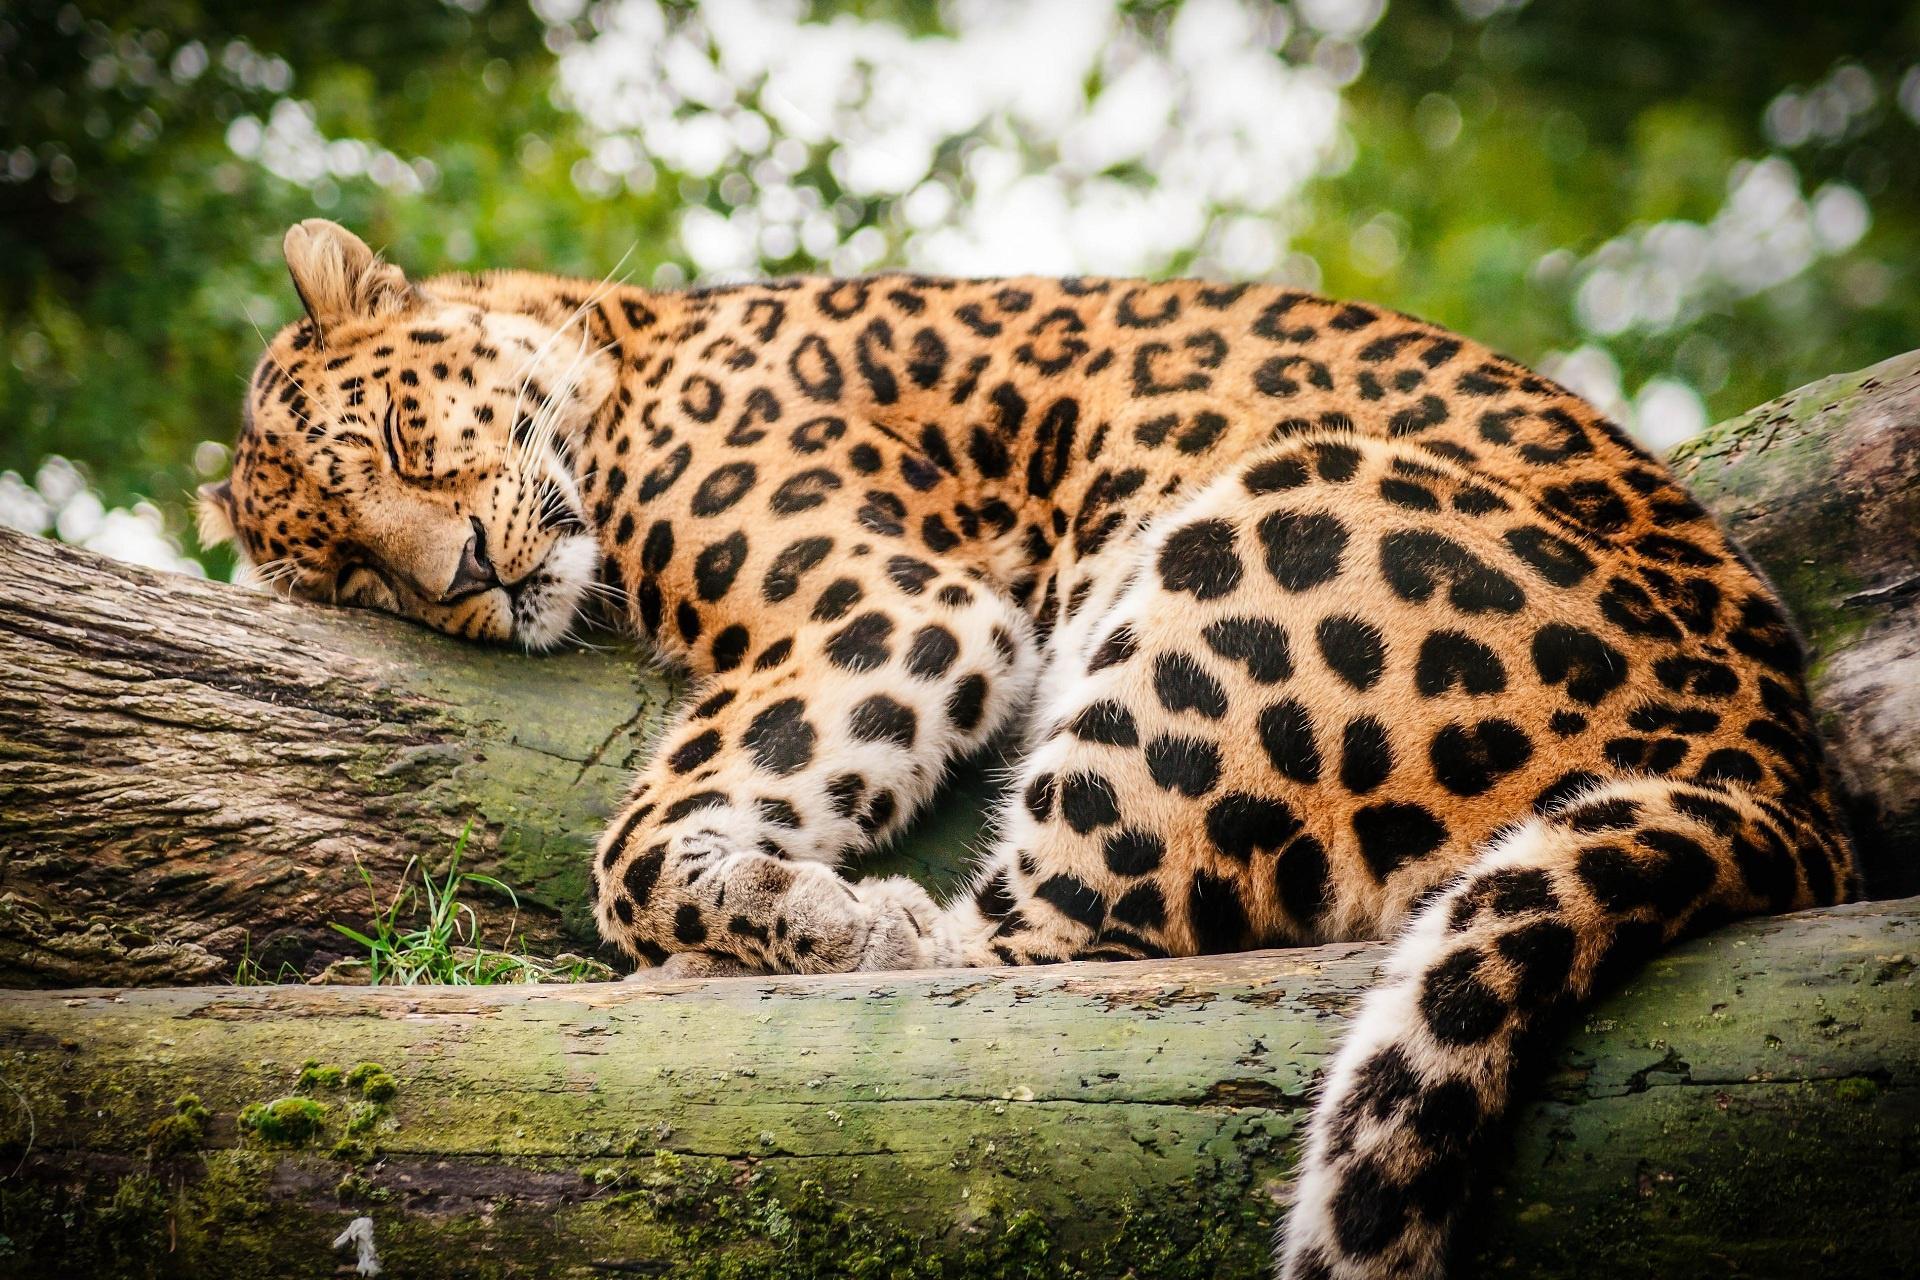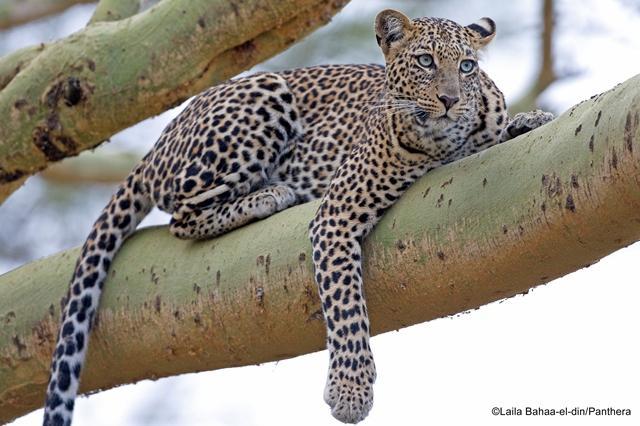The first image is the image on the left, the second image is the image on the right. Analyze the images presented: Is the assertion "In at least one image there is a spotted leopard sleeping with his head on a large branch hiding their second ear." valid? Answer yes or no. Yes. The first image is the image on the left, the second image is the image on the right. Analyze the images presented: Is the assertion "Only one of the two leopards is asleep, and neither is showing its tongue." valid? Answer yes or no. Yes. 